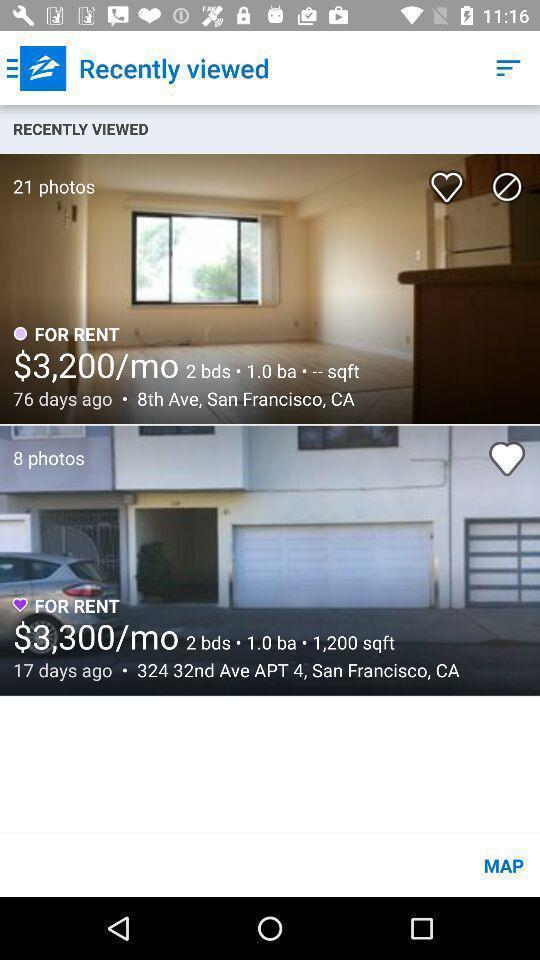Summarize the information in this screenshot. Screen showing the recently viewed flats for rent. 